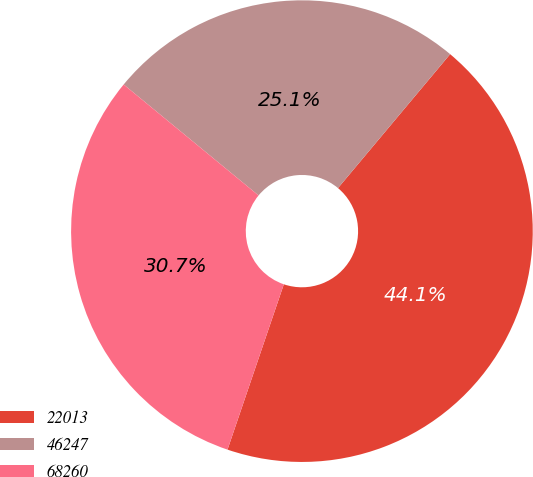Convert chart to OTSL. <chart><loc_0><loc_0><loc_500><loc_500><pie_chart><fcel>22013<fcel>46247<fcel>68260<nl><fcel>44.13%<fcel>25.14%<fcel>30.73%<nl></chart> 